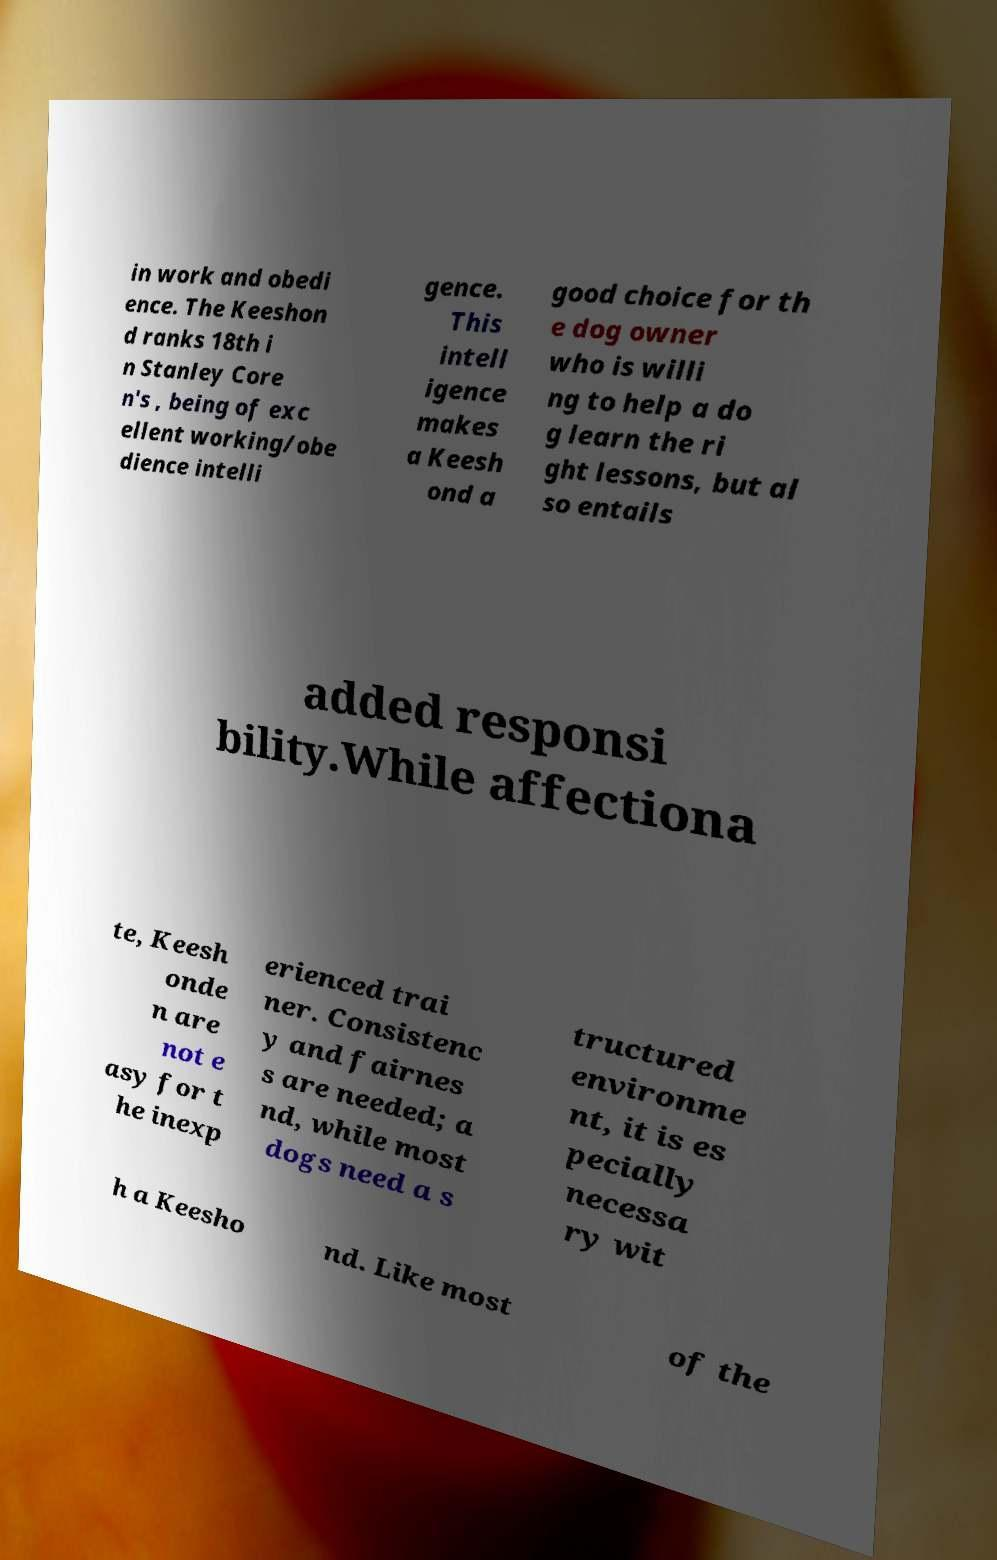I need the written content from this picture converted into text. Can you do that? in work and obedi ence. The Keeshon d ranks 18th i n Stanley Core n's , being of exc ellent working/obe dience intelli gence. This intell igence makes a Keesh ond a good choice for th e dog owner who is willi ng to help a do g learn the ri ght lessons, but al so entails added responsi bility.While affectiona te, Keesh onde n are not e asy for t he inexp erienced trai ner. Consistenc y and fairnes s are needed; a nd, while most dogs need a s tructured environme nt, it is es pecially necessa ry wit h a Keesho nd. Like most of the 